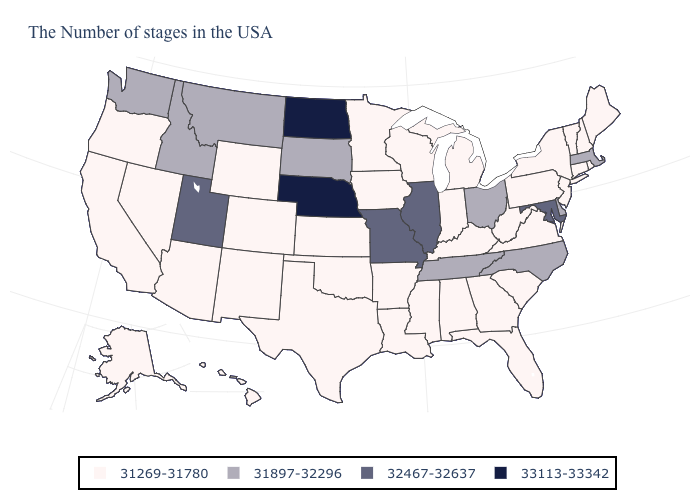Does the map have missing data?
Quick response, please. No. Does Virginia have a lower value than Nebraska?
Quick response, please. Yes. What is the value of Wisconsin?
Keep it brief. 31269-31780. Among the states that border Montana , does Idaho have the lowest value?
Concise answer only. No. How many symbols are there in the legend?
Keep it brief. 4. Among the states that border Colorado , which have the highest value?
Write a very short answer. Nebraska. What is the lowest value in the USA?
Be succinct. 31269-31780. Which states have the lowest value in the South?
Give a very brief answer. Virginia, South Carolina, West Virginia, Florida, Georgia, Kentucky, Alabama, Mississippi, Louisiana, Arkansas, Oklahoma, Texas. Name the states that have a value in the range 31897-32296?
Quick response, please. Massachusetts, Delaware, North Carolina, Ohio, Tennessee, South Dakota, Montana, Idaho, Washington. Among the states that border Michigan , does Ohio have the lowest value?
Give a very brief answer. No. What is the lowest value in the MidWest?
Write a very short answer. 31269-31780. What is the value of Washington?
Short answer required. 31897-32296. Does Connecticut have a lower value than Nebraska?
Write a very short answer. Yes. 